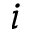<formula> <loc_0><loc_0><loc_500><loc_500>i</formula> 